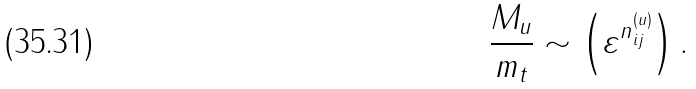<formula> <loc_0><loc_0><loc_500><loc_500>\frac { M _ { u } } { m _ { t } } \sim \left ( \varepsilon ^ { n ^ { ( u ) } _ { i j } } \right ) .</formula> 